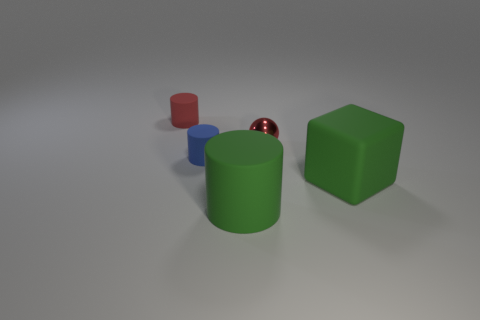Add 4 red things. How many objects exist? 9 Subtract all cylinders. How many objects are left? 2 Add 4 purple matte cylinders. How many purple matte cylinders exist? 4 Subtract 0 red blocks. How many objects are left? 5 Subtract all tiny things. Subtract all tiny gray rubber cylinders. How many objects are left? 2 Add 4 red things. How many red things are left? 6 